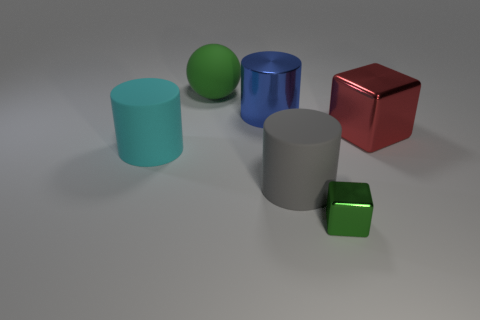Add 1 brown metal cubes. How many objects exist? 7 Subtract all balls. How many objects are left? 5 Subtract all matte spheres. Subtract all large gray matte cylinders. How many objects are left? 4 Add 6 large balls. How many large balls are left? 7 Add 2 blue things. How many blue things exist? 3 Subtract 1 cyan cylinders. How many objects are left? 5 